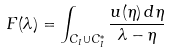Convert formula to latex. <formula><loc_0><loc_0><loc_500><loc_500>F ( \lambda ) = \int _ { C _ { I } \cup C _ { I } ^ { * } } \frac { u ( \eta ) \, d \eta } { \lambda - \eta }</formula> 